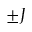Convert formula to latex. <formula><loc_0><loc_0><loc_500><loc_500>\pm J</formula> 